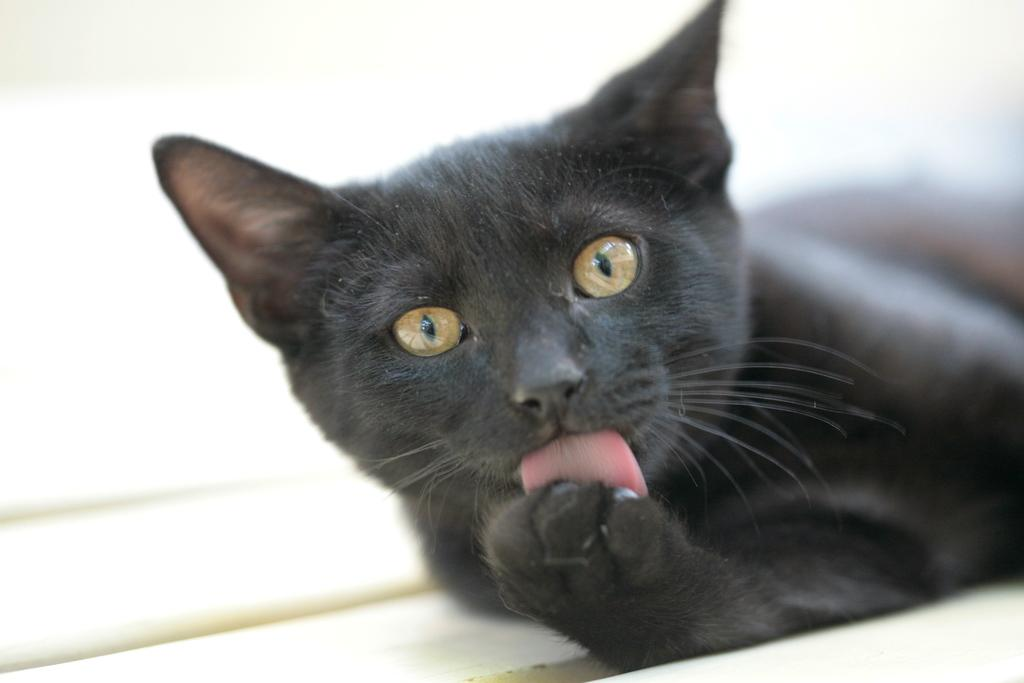What type of animal is in the image? There is a cat in the image. What color is the cat? The cat is black in color. What is the background of the image? The background of the image is white. Where is the nearest market to the cat in the image? There is no information about a market or its location in the image, so it cannot be determined. 